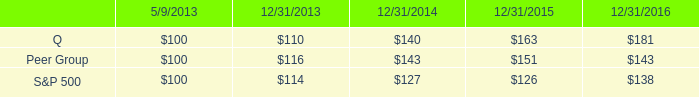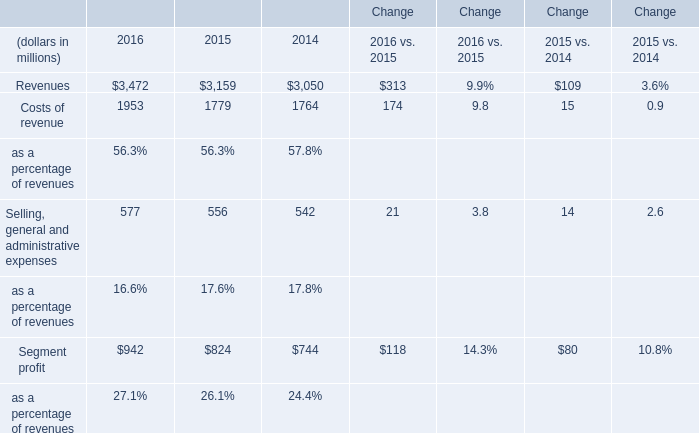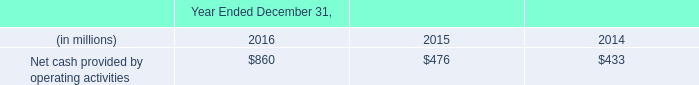Does the value of Revenues in 2015 greater than that in 2016? 
Answer: no. 